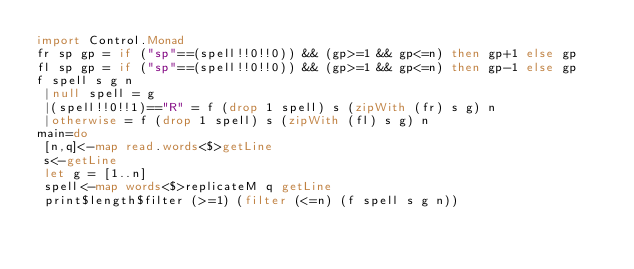Convert code to text. <code><loc_0><loc_0><loc_500><loc_500><_Haskell_>import Control.Monad
fr sp gp = if ("sp"==(spell!!0!!0)) && (gp>=1 && gp<=n) then gp+1 else gp
fl sp gp = if ("sp"==(spell!!0!!0)) && (gp>=1 && gp<=n) then gp-1 else gp
f spell s g n
 |null spell = g
 |(spell!!0!!1)=="R" = f (drop 1 spell) s (zipWith (fr) s g) n
 |otherwise = f (drop 1 spell) s (zipWith (fl) s g) n
main=do
 [n,q]<-map read.words<$>getLine
 s<-getLine
 let g = [1..n]
 spell<-map words<$>replicateM q getLine
 print$length$filter (>=1) (filter (<=n) (f spell s g n))</code> 